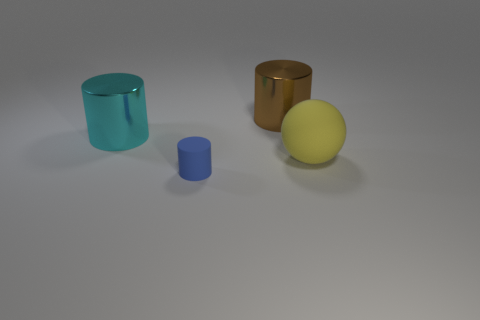Is there anything else that is the same size as the matte cylinder?
Ensure brevity in your answer.  No. What number of large objects are either metal cylinders or blue cylinders?
Give a very brief answer. 2. The large object behind the large metal cylinder in front of the big object that is behind the large cyan object is what color?
Provide a short and direct response. Brown. How many other things are there of the same color as the small cylinder?
Make the answer very short. 0. How many metal objects are either big red balls or brown cylinders?
Offer a very short reply. 1. Do the big object that is in front of the cyan object and the matte thing in front of the big yellow rubber sphere have the same color?
Your answer should be compact. No. Is there any other thing that has the same material as the large cyan cylinder?
Provide a succinct answer. Yes. The other shiny object that is the same shape as the brown object is what size?
Your answer should be compact. Large. Is the number of large cyan metallic cylinders on the right side of the tiny blue thing greater than the number of cyan metal objects?
Offer a terse response. No. Is the material of the sphere to the right of the cyan thing the same as the cyan cylinder?
Provide a short and direct response. No. 